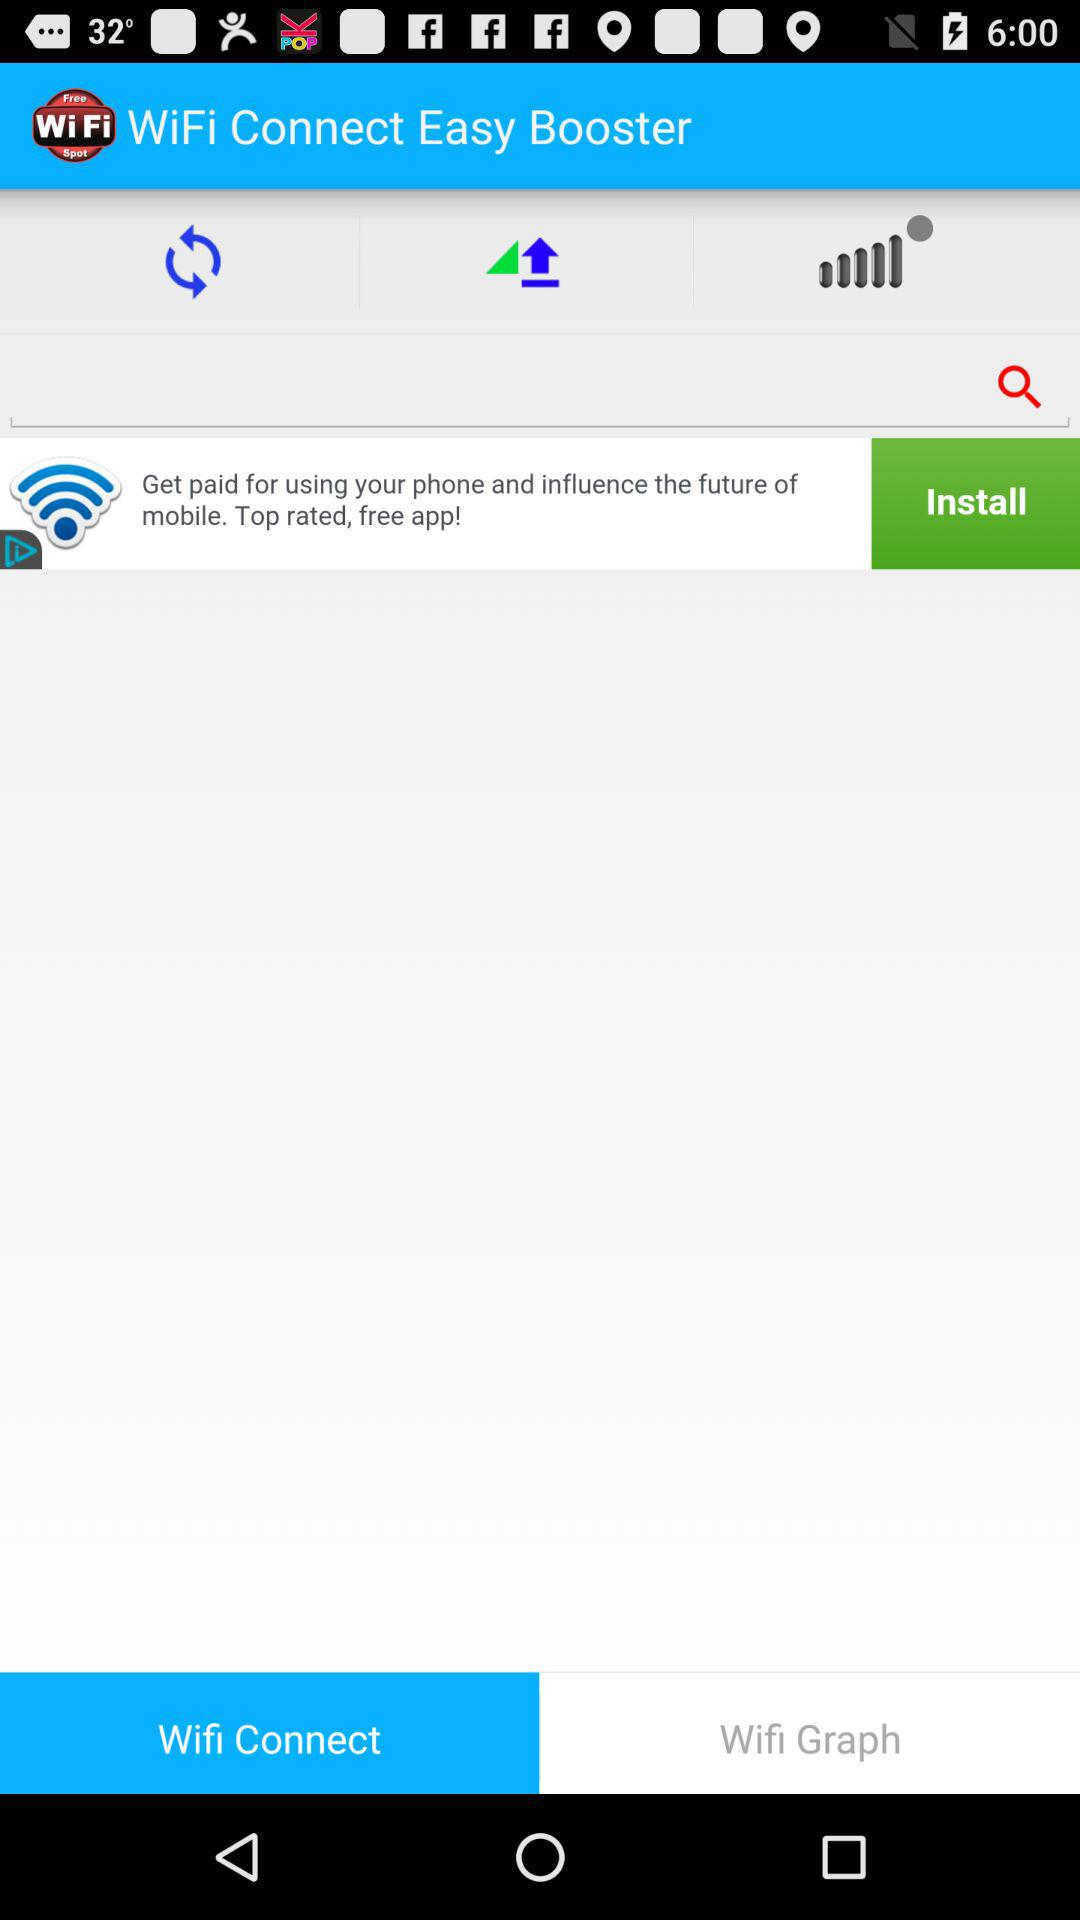What is the name of the application? The name of the application is "WiFi Connect Easy Booster". 